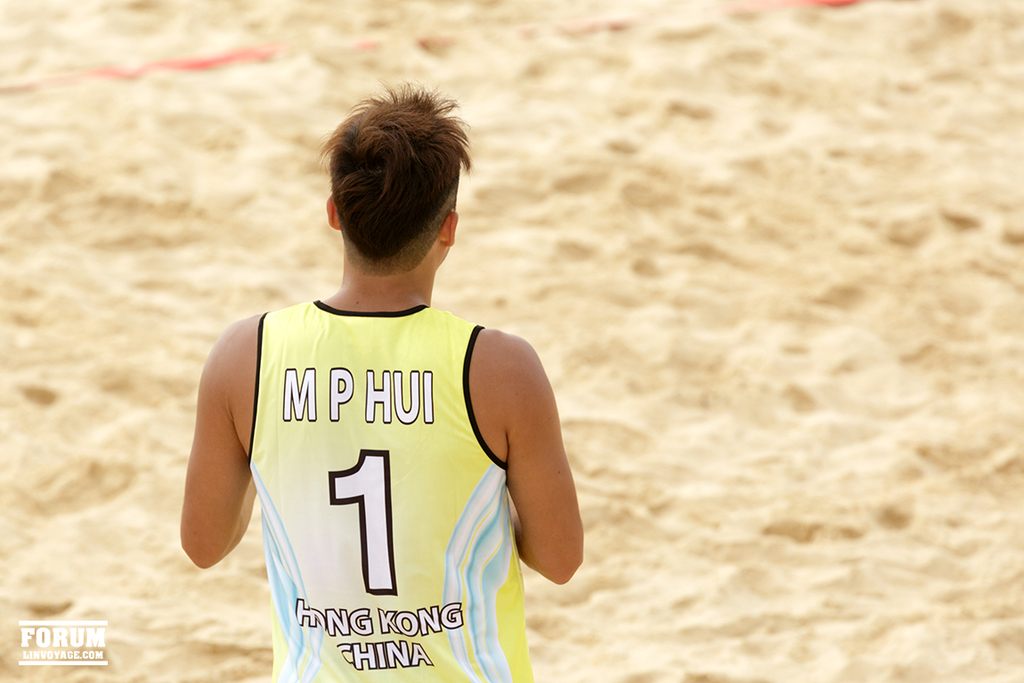Provide a one-sentence caption for the provided image.
Reference OCR token: M, MPHUI, P, HUI, 1, FORUM, HING, KONG, LINVOYACE.COM, HINA Guy with a yellow jersey for hong kong china is standing on sand. 